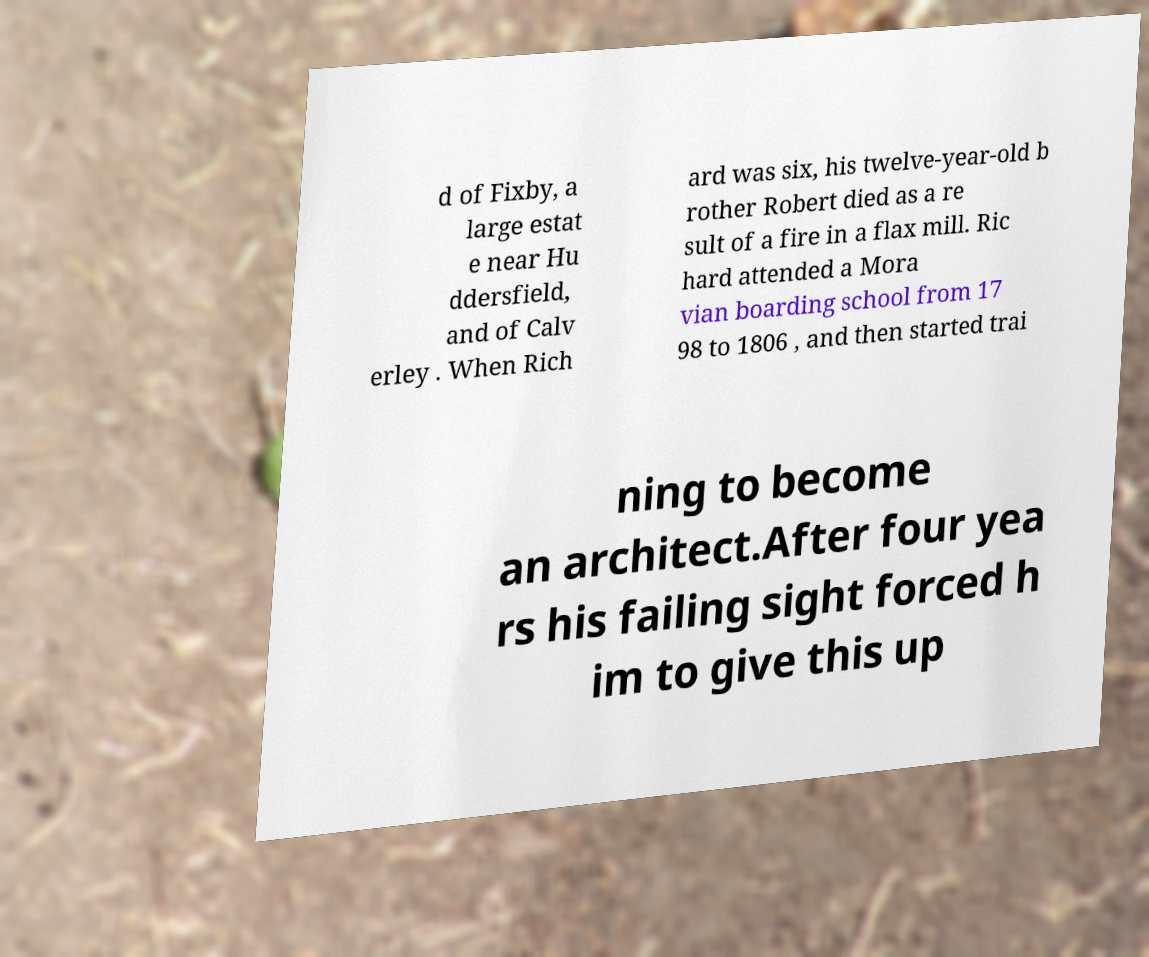Could you assist in decoding the text presented in this image and type it out clearly? d of Fixby, a large estat e near Hu ddersfield, and of Calv erley . When Rich ard was six, his twelve-year-old b rother Robert died as a re sult of a fire in a flax mill. Ric hard attended a Mora vian boarding school from 17 98 to 1806 , and then started trai ning to become an architect.After four yea rs his failing sight forced h im to give this up 